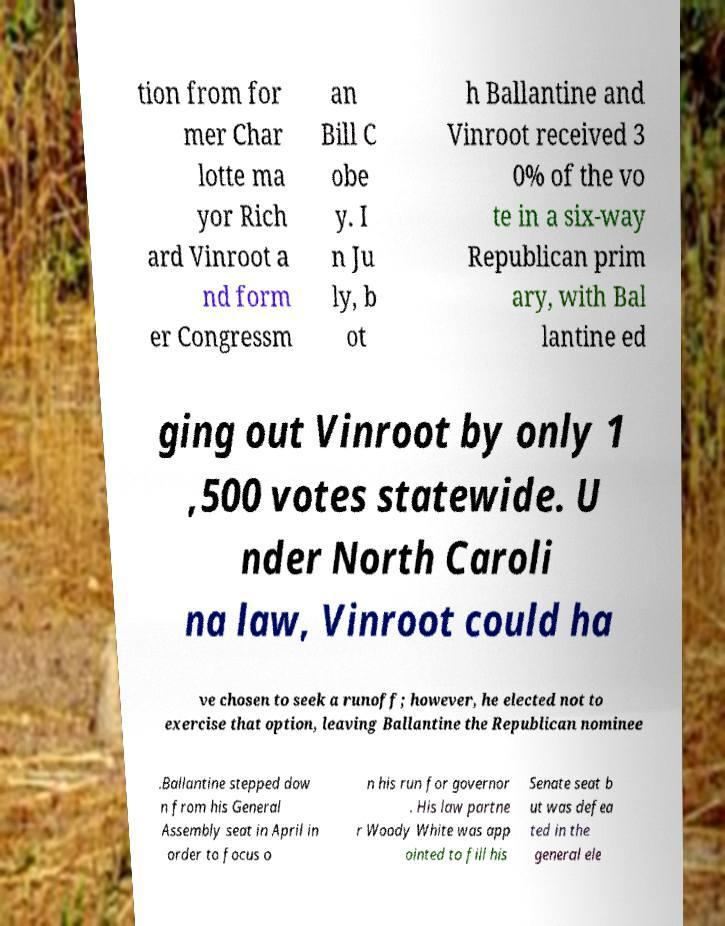I need the written content from this picture converted into text. Can you do that? tion from for mer Char lotte ma yor Rich ard Vinroot a nd form er Congressm an Bill C obe y. I n Ju ly, b ot h Ballantine and Vinroot received 3 0% of the vo te in a six-way Republican prim ary, with Bal lantine ed ging out Vinroot by only 1 ,500 votes statewide. U nder North Caroli na law, Vinroot could ha ve chosen to seek a runoff; however, he elected not to exercise that option, leaving Ballantine the Republican nominee .Ballantine stepped dow n from his General Assembly seat in April in order to focus o n his run for governor . His law partne r Woody White was app ointed to fill his Senate seat b ut was defea ted in the general ele 